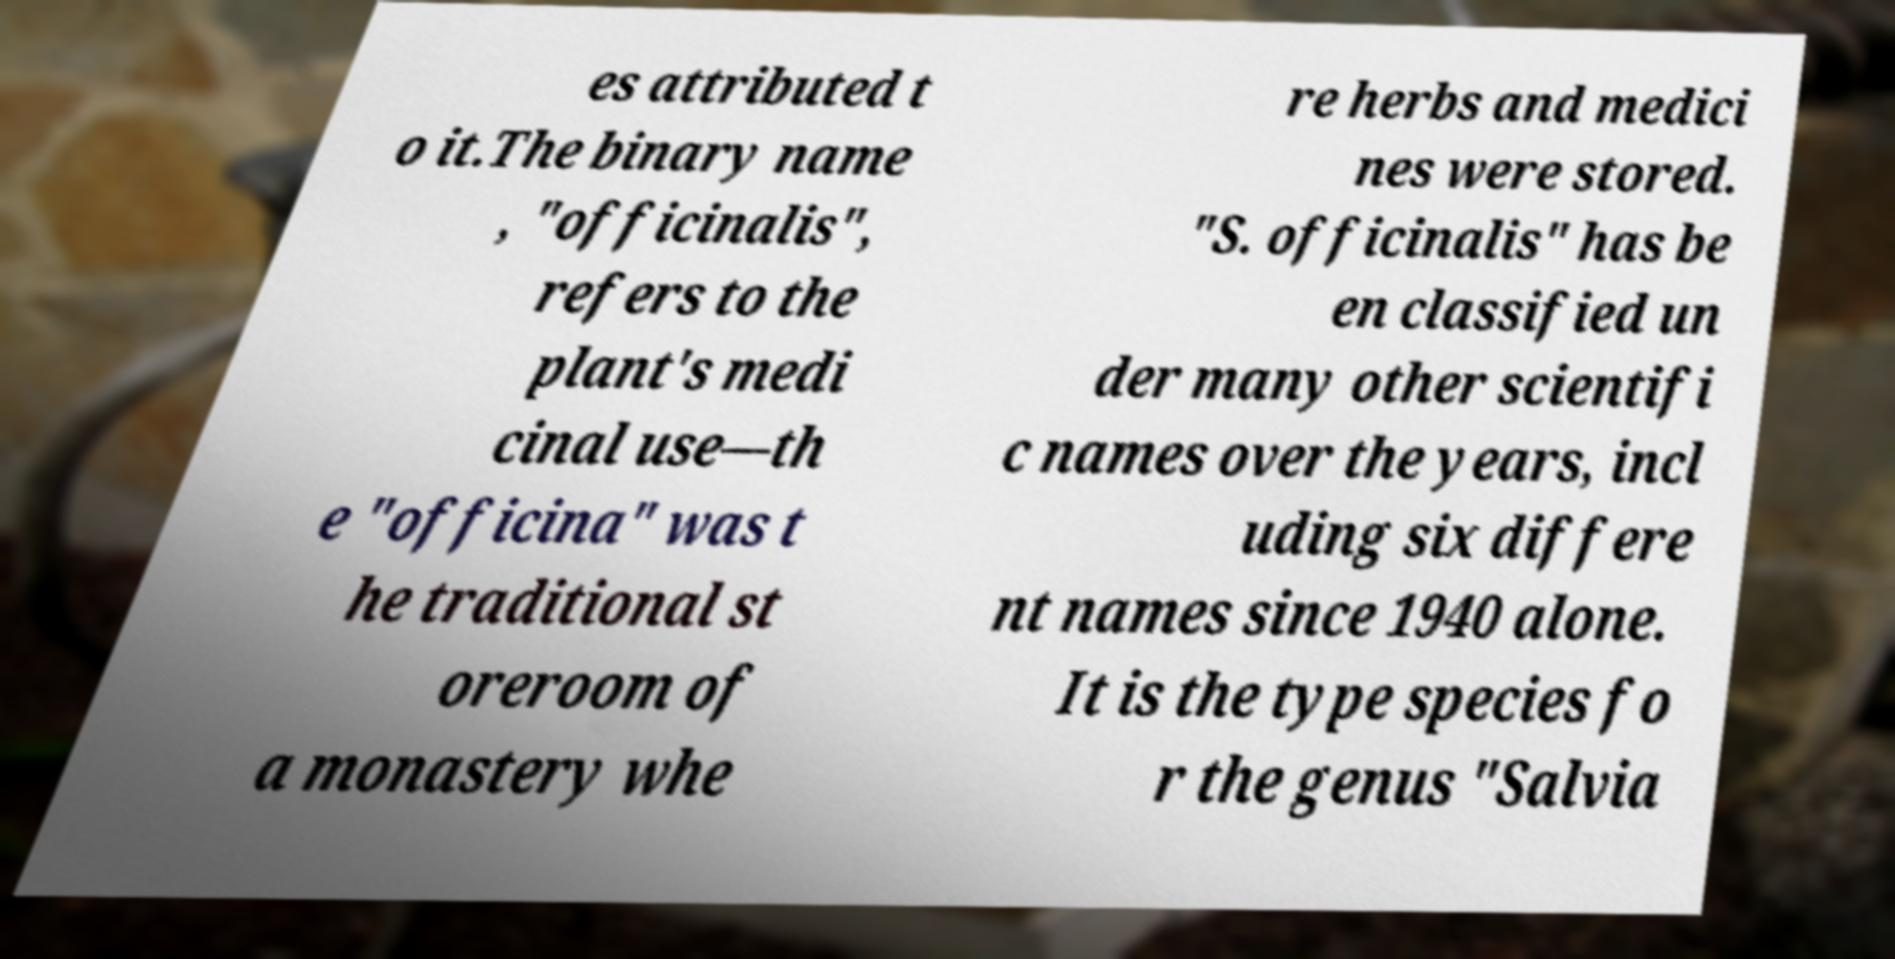There's text embedded in this image that I need extracted. Can you transcribe it verbatim? es attributed t o it.The binary name , "officinalis", refers to the plant's medi cinal use—th e "officina" was t he traditional st oreroom of a monastery whe re herbs and medici nes were stored. "S. officinalis" has be en classified un der many other scientifi c names over the years, incl uding six differe nt names since 1940 alone. It is the type species fo r the genus "Salvia 